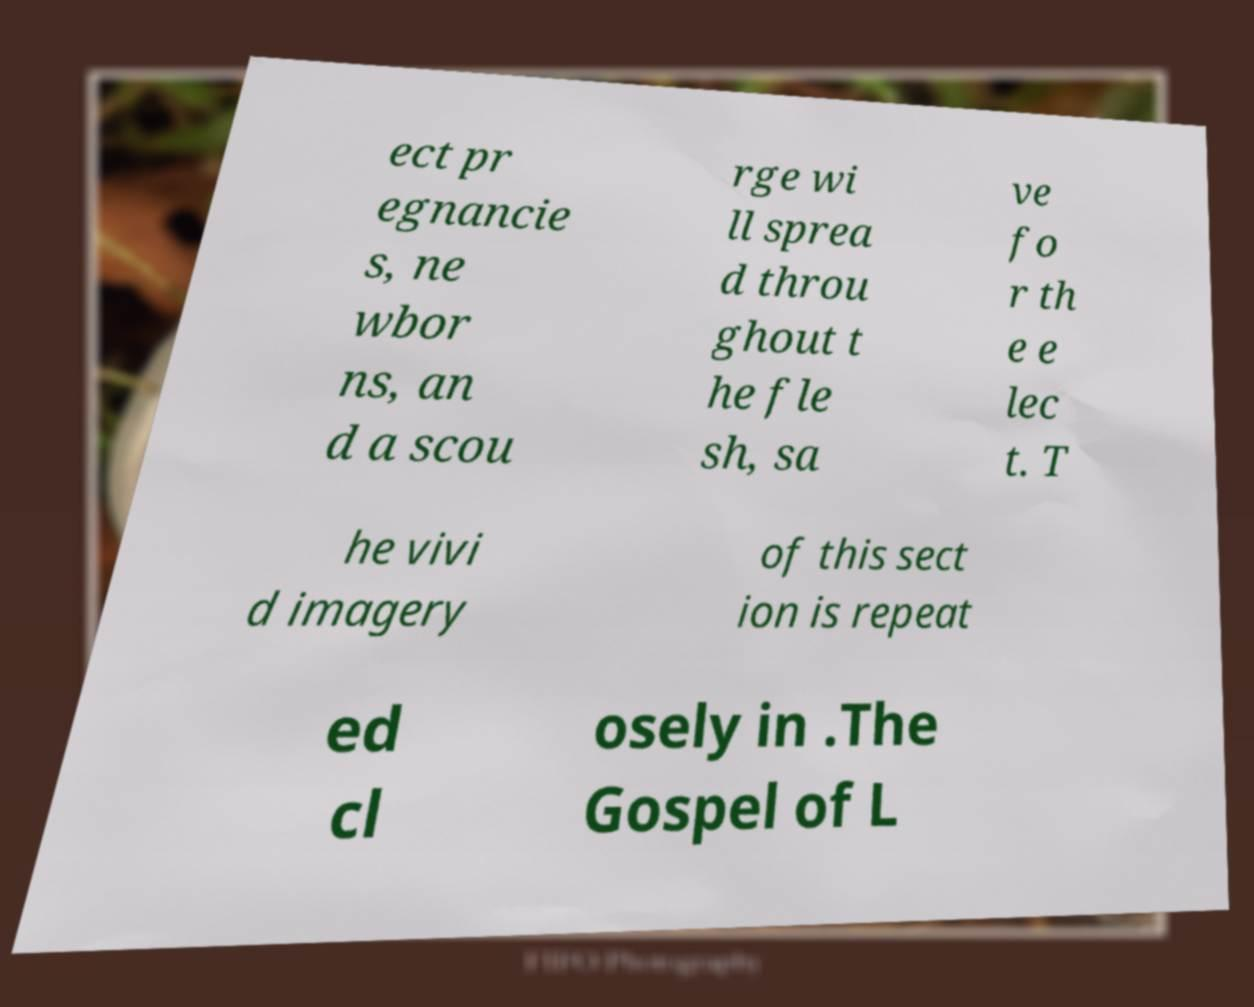Please identify and transcribe the text found in this image. ect pr egnancie s, ne wbor ns, an d a scou rge wi ll sprea d throu ghout t he fle sh, sa ve fo r th e e lec t. T he vivi d imagery of this sect ion is repeat ed cl osely in .The Gospel of L 